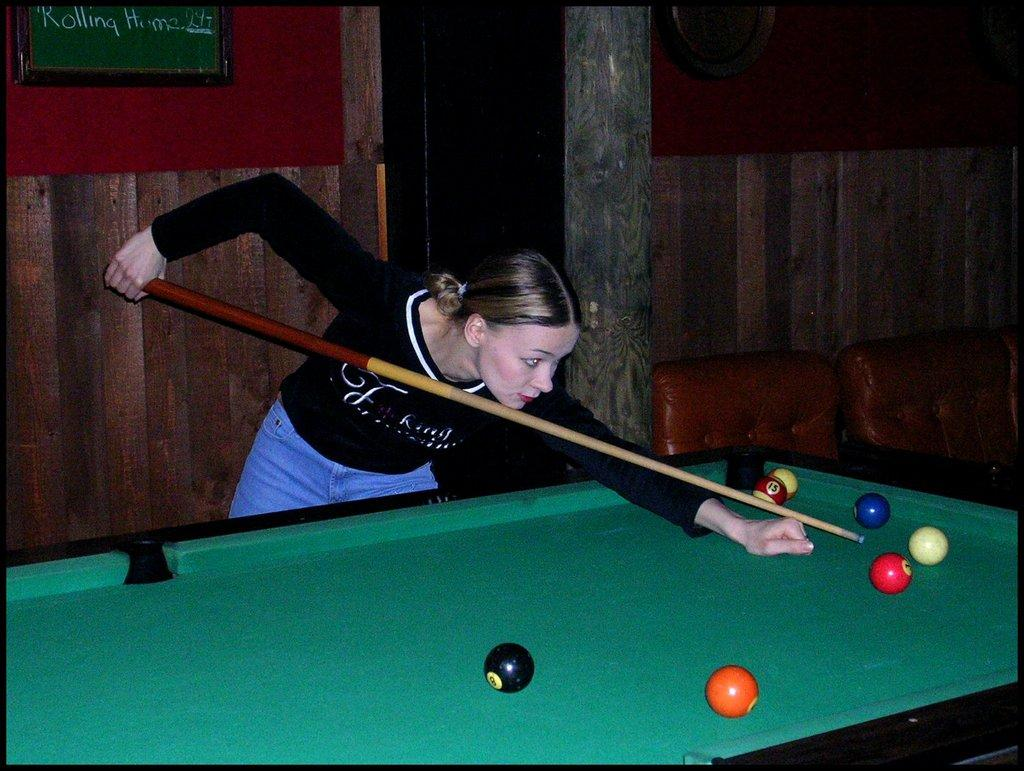Who is the main subject in the image? There is a woman in the image. What is the woman wearing? The woman is wearing a black T-shirt. What activity is the woman engaged in? The woman is playing a billiards game. Are there any horses participating in the billiards game in the image? No, there are no horses present in the image, and they are not participating in the billiards game. 